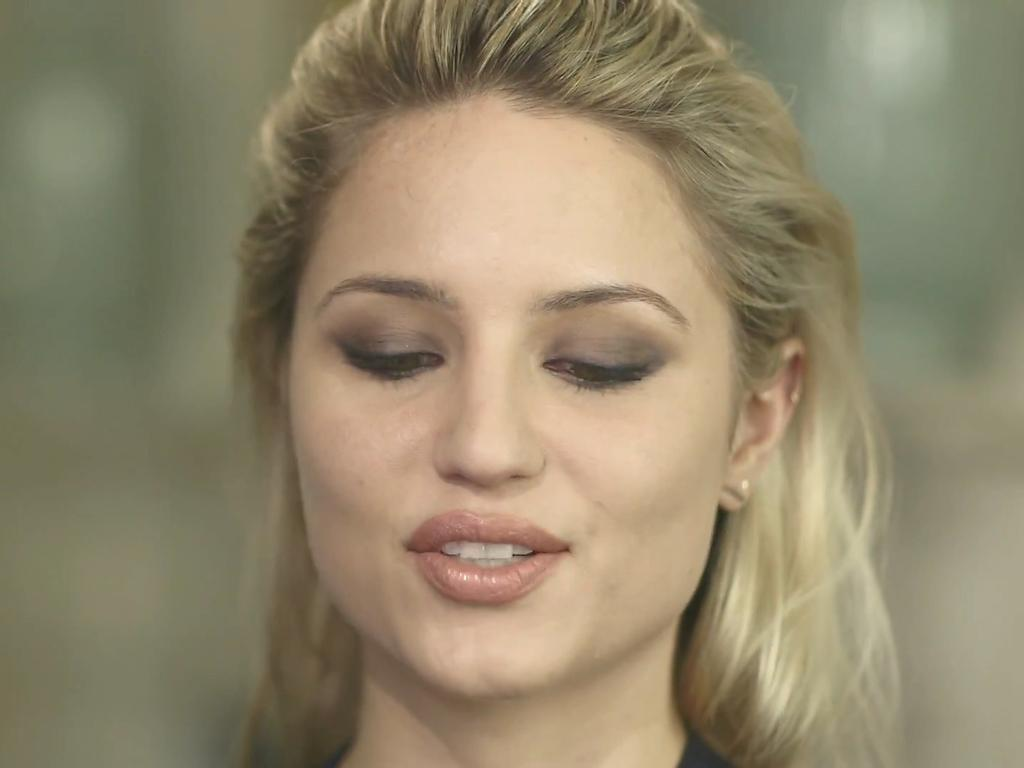Who is present in the image? There is a woman in the image. What expression does the woman have? The woman is smiling. Can you describe the background of the image? The background of the image is blurry. What type of marble is the woman holding in the image? There is no marble present in the image; the woman is not holding anything. 